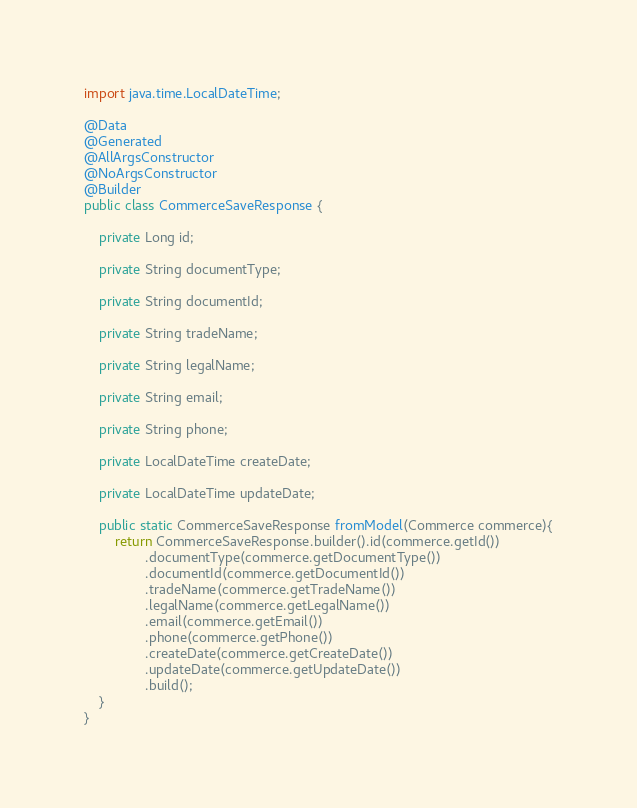<code> <loc_0><loc_0><loc_500><loc_500><_Java_>
import java.time.LocalDateTime;

@Data
@Generated
@AllArgsConstructor
@NoArgsConstructor
@Builder
public class CommerceSaveResponse {

    private Long id;

    private String documentType;

    private String documentId;

    private String tradeName;

    private String legalName;

    private String email;

    private String phone;

    private LocalDateTime createDate;

    private LocalDateTime updateDate;

    public static CommerceSaveResponse fromModel(Commerce commerce){
        return CommerceSaveResponse.builder().id(commerce.getId())
                .documentType(commerce.getDocumentType())
                .documentId(commerce.getDocumentId())
                .tradeName(commerce.getTradeName())
                .legalName(commerce.getLegalName())
                .email(commerce.getEmail())
                .phone(commerce.getPhone())
                .createDate(commerce.getCreateDate())
                .updateDate(commerce.getUpdateDate())
                .build();
    }
}
</code> 